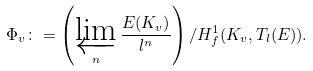<formula> <loc_0><loc_0><loc_500><loc_500>\Phi _ { v } \colon = \left ( \varprojlim _ { n } \frac { E ( K _ { v } ) } { l ^ { n } } \right ) / H ^ { 1 } _ { f } ( K _ { v } , T _ { l } ( E ) ) .</formula> 